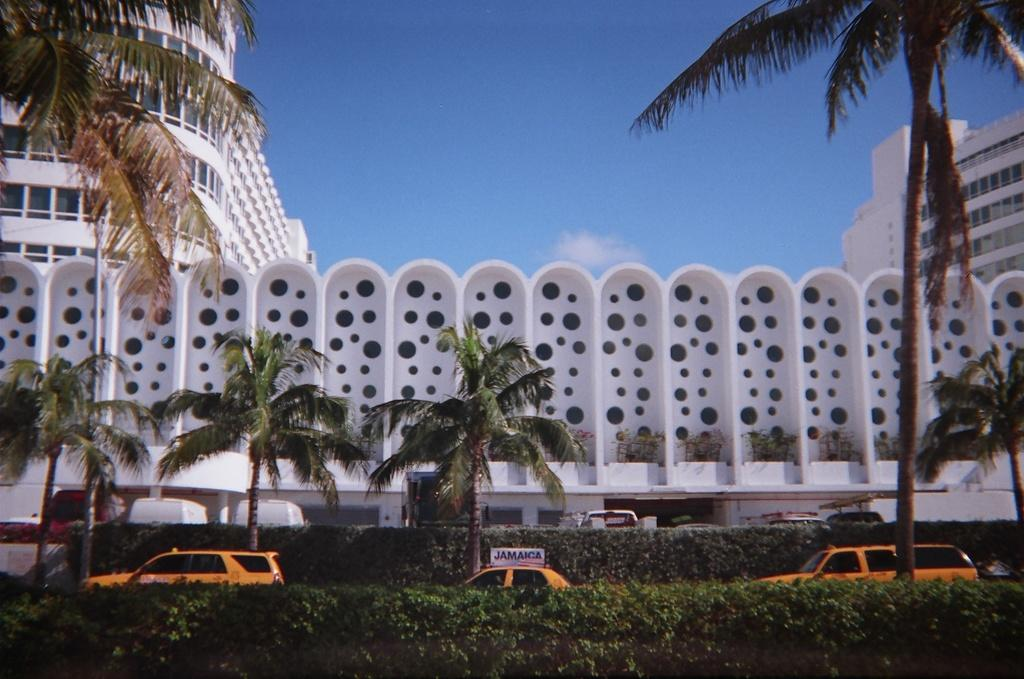What celestial bodies areal bodies are present in the image? There are planets in the image. What type of man-made objects can be seen in the image? There are cars in the image. What type of natural vegetation is present in the image? There are trees in the image. What type of structures are present in the image? There are buildings in the image. What is visible at the top of the image? The sky is visible at the top of the image. Can you tell me how many rats are sitting on the bottle in the image? There are no rats or bottles present in the image. What type of lock is used on the car in the image? There are no locks visible in the image, and the image does not show any cars with locks. 